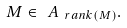Convert formula to latex. <formula><loc_0><loc_0><loc_500><loc_500>M \in \ A _ { \ r a n k ( M ) } .</formula> 